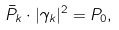<formula> <loc_0><loc_0><loc_500><loc_500>\bar { P } _ { k } \cdot | \gamma _ { k } | ^ { 2 } = P _ { 0 } ,</formula> 